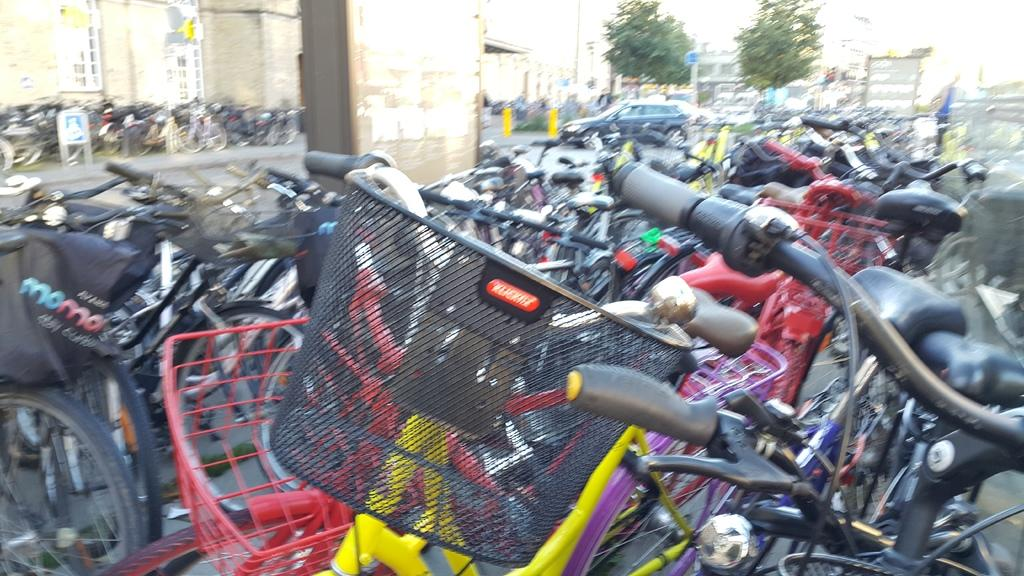What type of vehicles can be seen in the background of the image? Vehicles are visible in the background of the image, but the specific types cannot be determined from the facts provided. What is the location of the bicycles in the image? The bicycles are placed on the road in the image. What is the main object in the middle of the image? There is a pillar in the middle of the image. What can be seen in the background of the image besides vehicles? There is at least one building and trees present in the background of the image. What type of chess pieces can be seen on the road in the image? There is no mention of chess pieces in the image; it features bicycles on the road. What color is the chalk used to draw on the pillar in the image? There is no chalk or drawing on the pillar in the image. 